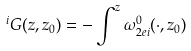Convert formula to latex. <formula><loc_0><loc_0><loc_500><loc_500>{ } ^ { i } G ( z , z _ { 0 } ) = - \int ^ { z } \omega _ { 2 e i } ^ { 0 } ( \cdot , z _ { 0 } )</formula> 